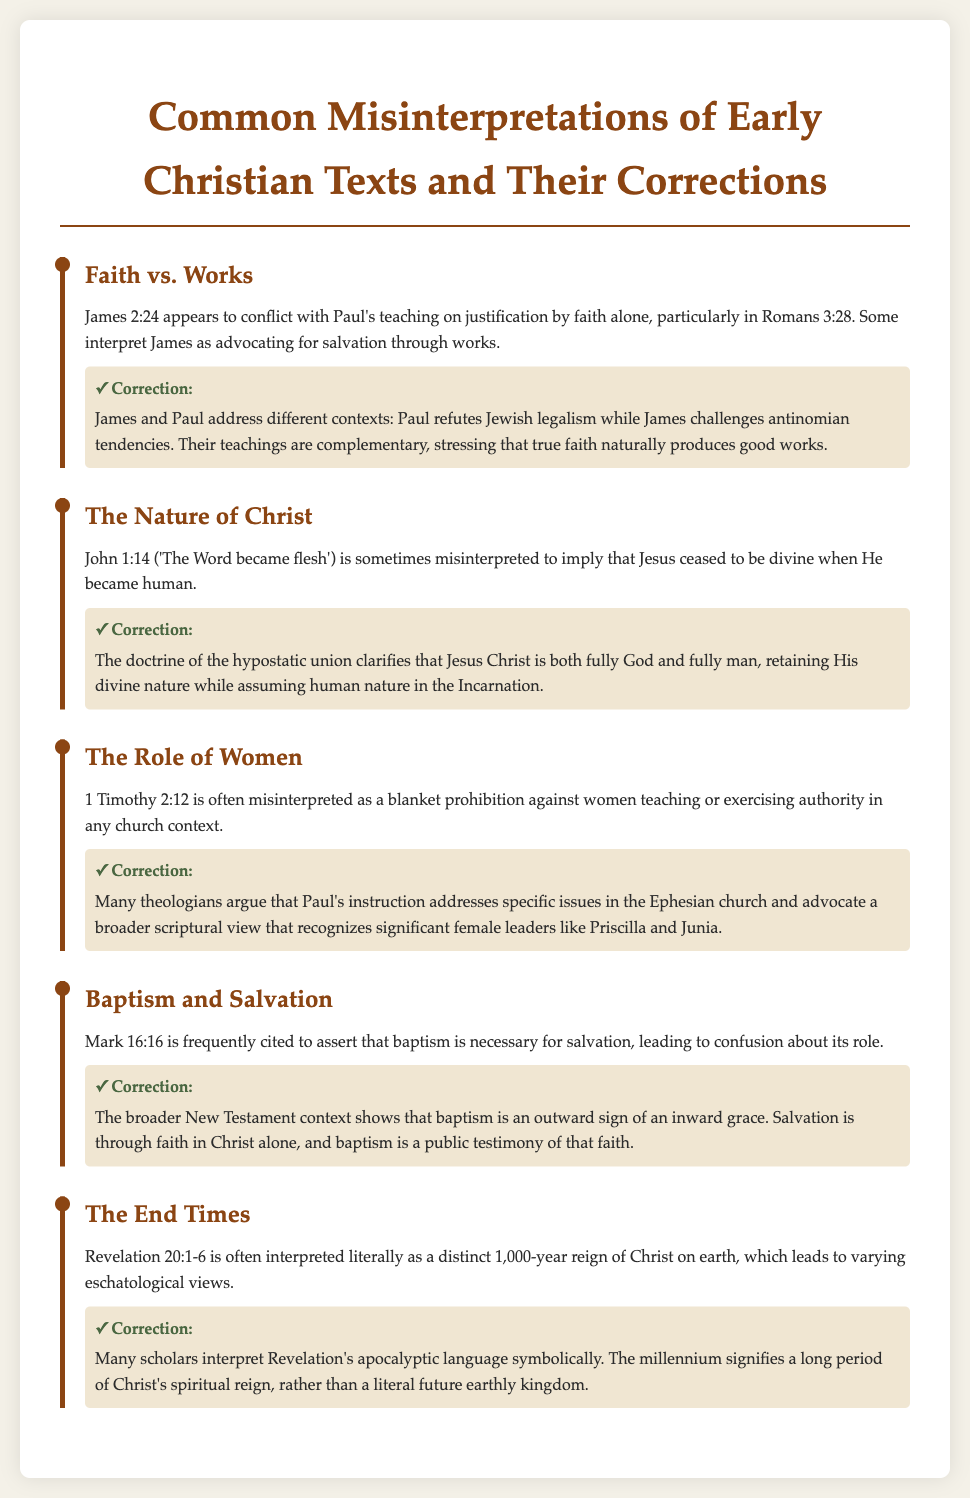What is the title of the document? The title is located at the top of the document, prominently displayed.
Answer: Common Misinterpretations of Early Christian Texts and Their Corrections How many items are listed in the document? The number of items refers to the distinct topics covered, each under its own heading.
Answer: Five Which book of the Bible is referenced regarding the nature of Christ? The book mentioned specifically relates to the quote discussing the Incarnation of Jesus.
Answer: John What is the correction regarding baptism and salvation? This correction explains the role of baptism in the context of faith and salvation.
Answer: The broader New Testament context shows that baptism is an outward sign of an inward grace Who are two significant female leaders mentioned in the document? These women serve as examples to counter the infrequent interpretation of women's roles in church.
Answer: Priscilla and Junia What specific verse is often misinterpreted concerning the role of women? This verse is highlighted to address the context of women's authority in teaching.
Answer: 1 Timothy 2:12 What doctrine clarifies the nature of Christ according to the document? This doctrine is vital for understanding the dual nature of Jesus Christ in Christian theology.
Answer: The doctrine of the hypostatic union Which part of the New Testament addresses the faith versus works debate? This part is crucial for discussing different views on salvation and justification.
Answer: James 2:24 